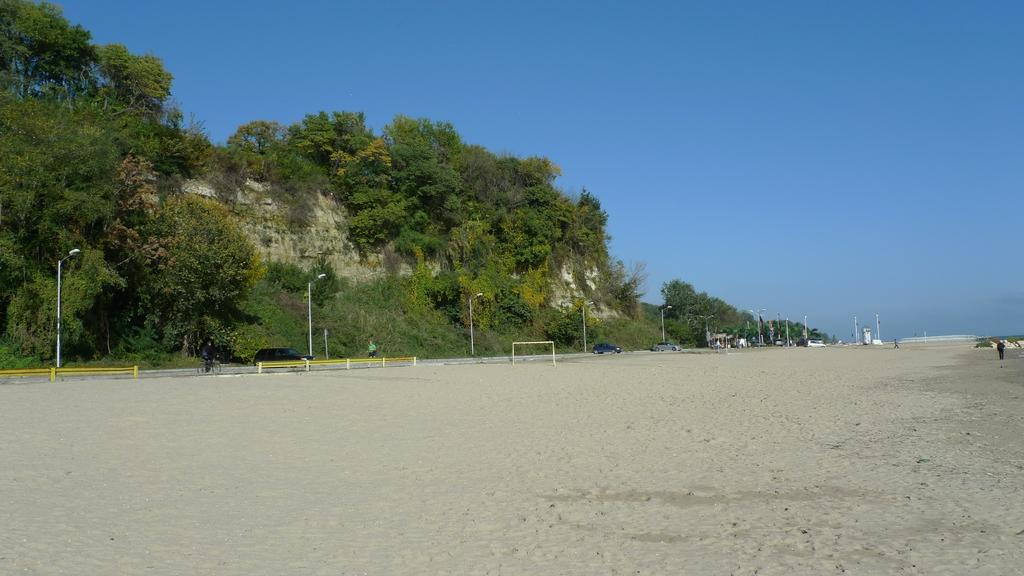What is at the bottom of the image in the image? There is sand at the bottom of the image. What can be seen in the background of the image? In the background of the image, there are poles, benches, vehicles, and trees. What is visible at the top of the image? The sky is visible at the top of the image. What type of approval is being given by the bells in the image? There are no bells present in the image, so it is not possible to determine if any approval is being given. 